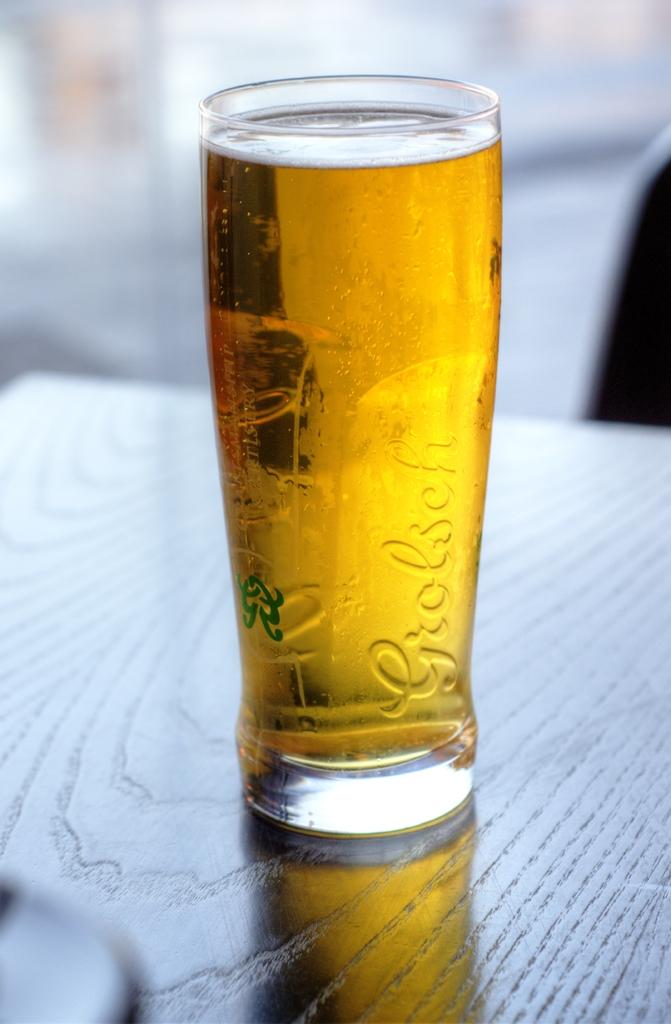What name is etched in the glass?
Offer a terse response. Grolsch. 